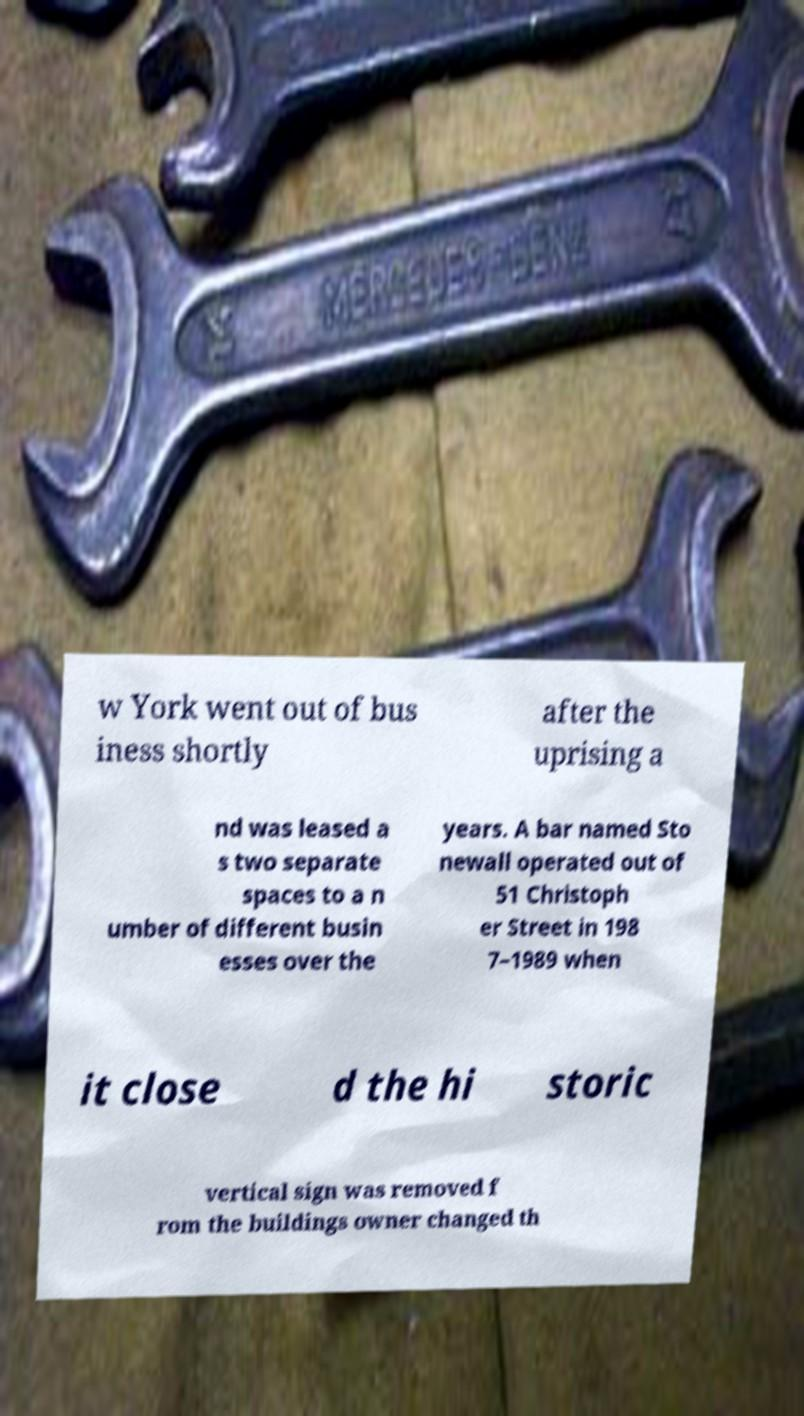Please read and relay the text visible in this image. What does it say? w York went out of bus iness shortly after the uprising a nd was leased a s two separate spaces to a n umber of different busin esses over the years. A bar named Sto newall operated out of 51 Christoph er Street in 198 7–1989 when it close d the hi storic vertical sign was removed f rom the buildings owner changed th 